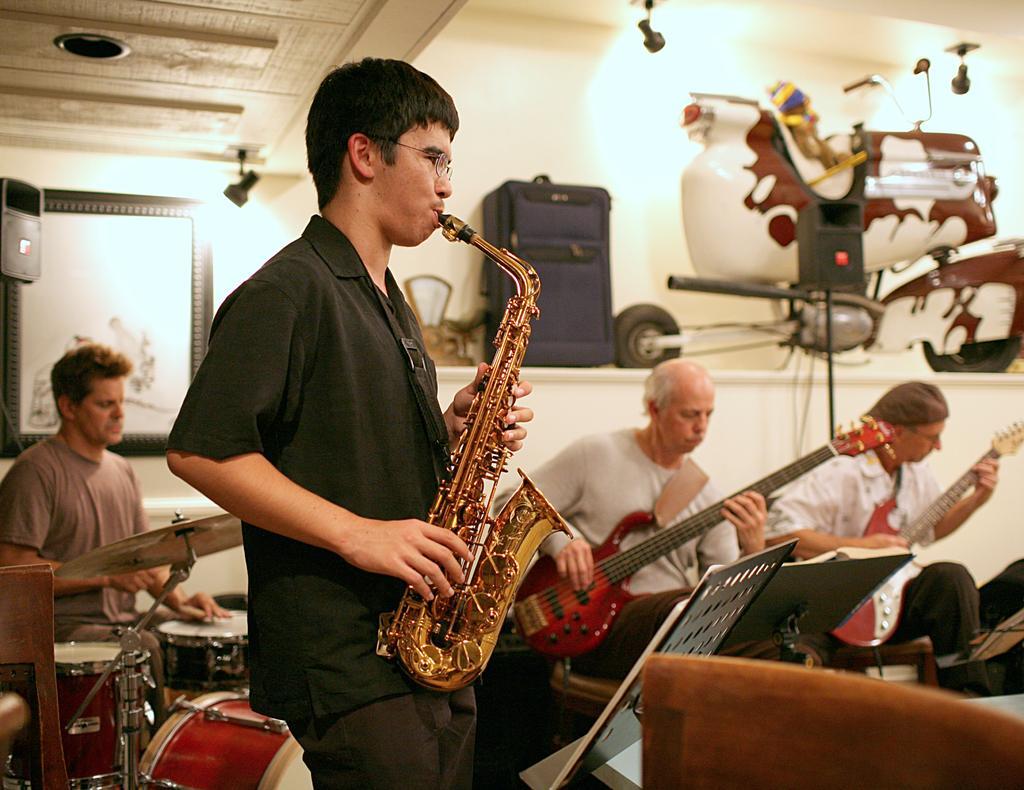Could you give a brief overview of what you see in this image? In this image i can see a man playing a musical instrument at the back ground i can see few other persons playing the musical instrument and a wall. 